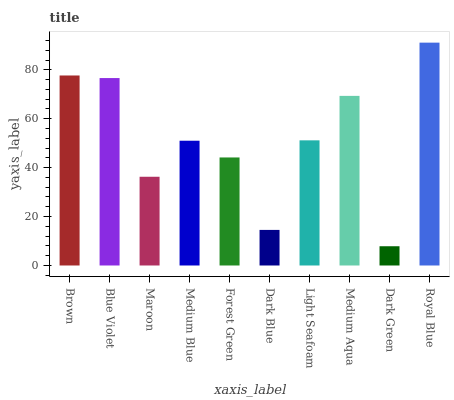Is Dark Green the minimum?
Answer yes or no. Yes. Is Royal Blue the maximum?
Answer yes or no. Yes. Is Blue Violet the minimum?
Answer yes or no. No. Is Blue Violet the maximum?
Answer yes or no. No. Is Brown greater than Blue Violet?
Answer yes or no. Yes. Is Blue Violet less than Brown?
Answer yes or no. Yes. Is Blue Violet greater than Brown?
Answer yes or no. No. Is Brown less than Blue Violet?
Answer yes or no. No. Is Light Seafoam the high median?
Answer yes or no. Yes. Is Medium Blue the low median?
Answer yes or no. Yes. Is Dark Green the high median?
Answer yes or no. No. Is Blue Violet the low median?
Answer yes or no. No. 